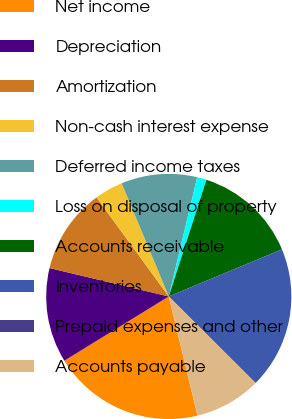Convert chart. <chart><loc_0><loc_0><loc_500><loc_500><pie_chart><fcel>Net income<fcel>Depreciation<fcel>Amortization<fcel>Non-cash interest expense<fcel>Deferred income taxes<fcel>Loss on disposal of property<fcel>Accounts receivable<fcel>Inventories<fcel>Prepaid expenses and other<fcel>Accounts payable<nl><fcel>19.99%<fcel>12.5%<fcel>11.25%<fcel>3.75%<fcel>10.0%<fcel>1.25%<fcel>13.75%<fcel>18.75%<fcel>0.01%<fcel>8.75%<nl></chart> 